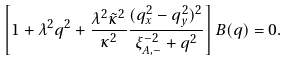Convert formula to latex. <formula><loc_0><loc_0><loc_500><loc_500>\left [ 1 + \lambda ^ { 2 } { q } ^ { 2 } + \frac { \lambda ^ { 2 } \tilde { \kappa } ^ { 2 } } { \kappa ^ { 2 } } \frac { ( q _ { x } ^ { 2 } - q _ { y } ^ { 2 } ) ^ { 2 } } { \xi _ { A , - } ^ { - 2 } + { q } ^ { 2 } } \right ] B ( { q } ) = 0 .</formula> 